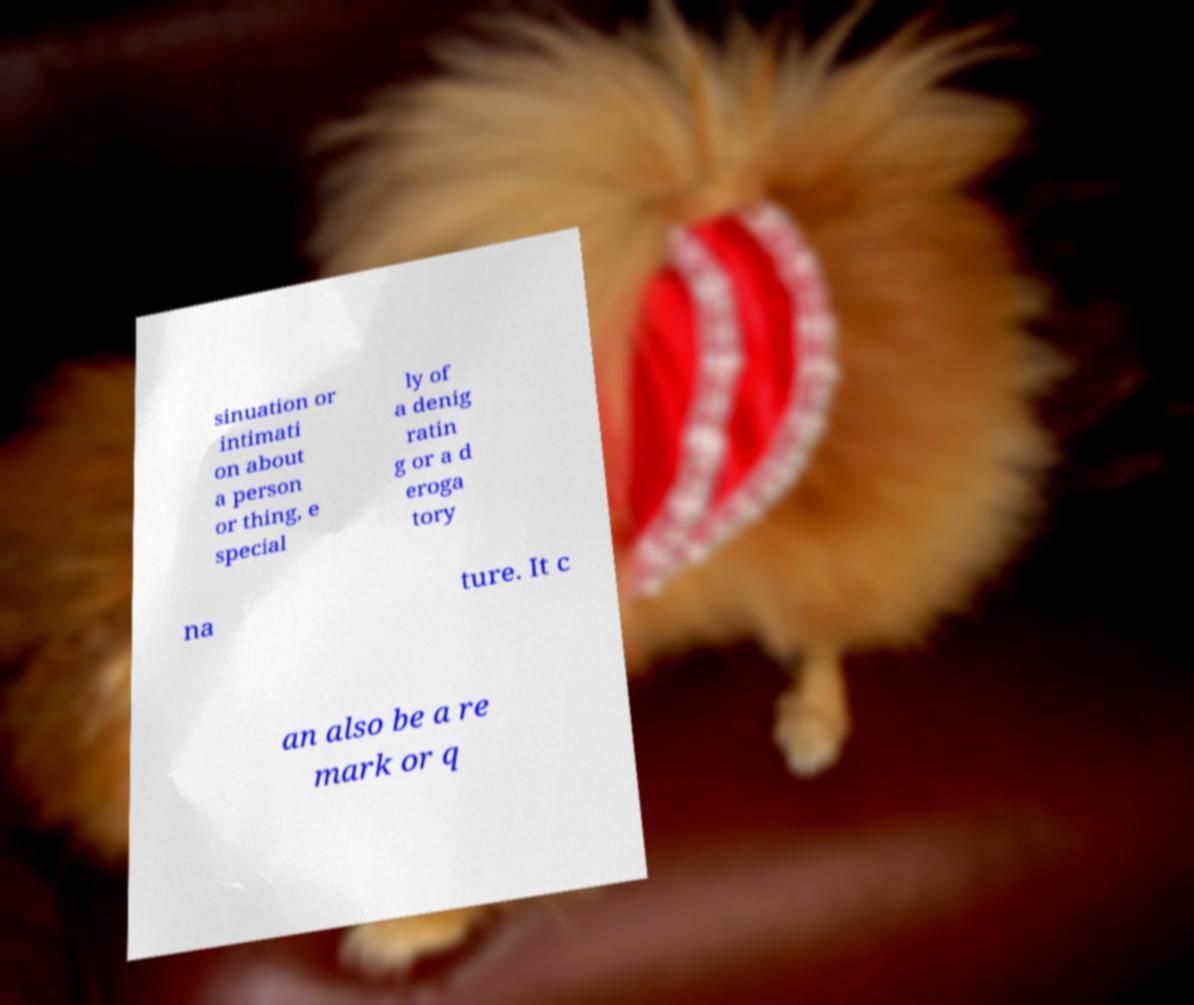There's text embedded in this image that I need extracted. Can you transcribe it verbatim? sinuation or intimati on about a person or thing, e special ly of a denig ratin g or a d eroga tory na ture. It c an also be a re mark or q 